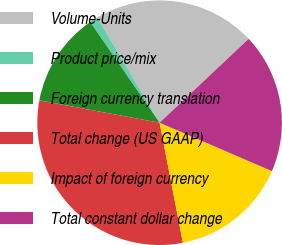<chart> <loc_0><loc_0><loc_500><loc_500><pie_chart><fcel>Volume-Units<fcel>Product price/mix<fcel>Foreign currency translation<fcel>Total change (US GAAP)<fcel>Impact of foreign currency<fcel>Total constant dollar change<nl><fcel>21.49%<fcel>1.09%<fcel>12.48%<fcel>30.98%<fcel>15.47%<fcel>18.5%<nl></chart> 